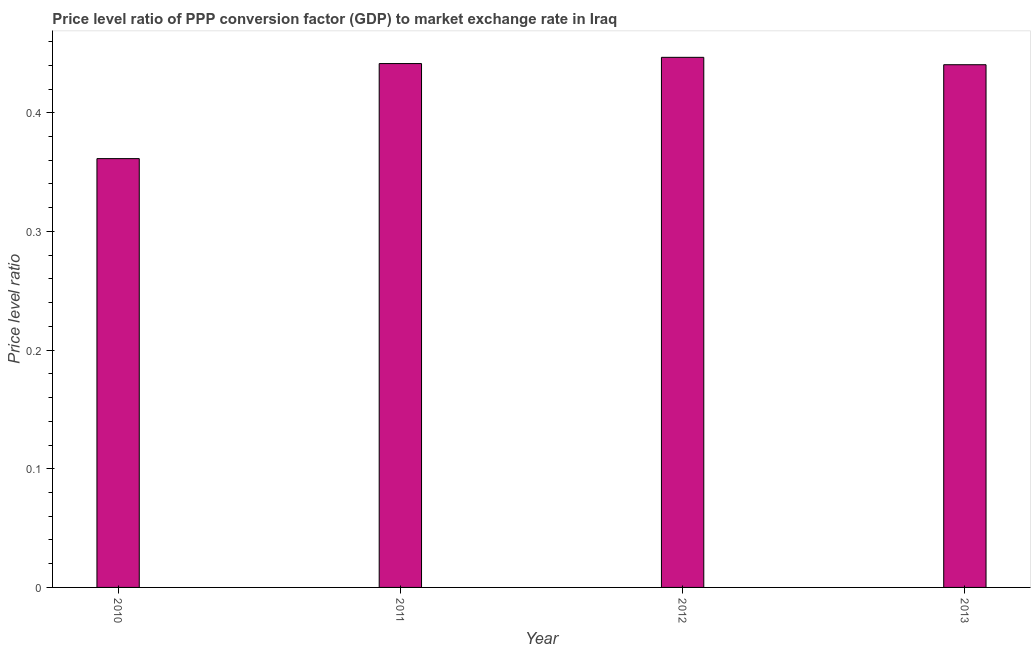What is the title of the graph?
Give a very brief answer. Price level ratio of PPP conversion factor (GDP) to market exchange rate in Iraq. What is the label or title of the Y-axis?
Your answer should be compact. Price level ratio. What is the price level ratio in 2013?
Your answer should be very brief. 0.44. Across all years, what is the maximum price level ratio?
Provide a succinct answer. 0.45. Across all years, what is the minimum price level ratio?
Your answer should be very brief. 0.36. In which year was the price level ratio maximum?
Your answer should be very brief. 2012. What is the sum of the price level ratio?
Your answer should be very brief. 1.69. What is the difference between the price level ratio in 2011 and 2012?
Provide a short and direct response. -0.01. What is the average price level ratio per year?
Provide a succinct answer. 0.42. What is the median price level ratio?
Ensure brevity in your answer.  0.44. Do a majority of the years between 2010 and 2012 (inclusive) have price level ratio greater than 0.14 ?
Your answer should be compact. Yes. Is the difference between the price level ratio in 2010 and 2013 greater than the difference between any two years?
Offer a terse response. No. What is the difference between the highest and the second highest price level ratio?
Your answer should be compact. 0.01. What is the difference between the highest and the lowest price level ratio?
Provide a short and direct response. 0.09. How many bars are there?
Provide a short and direct response. 4. Are all the bars in the graph horizontal?
Offer a very short reply. No. How many years are there in the graph?
Provide a succinct answer. 4. What is the difference between two consecutive major ticks on the Y-axis?
Offer a terse response. 0.1. Are the values on the major ticks of Y-axis written in scientific E-notation?
Your answer should be compact. No. What is the Price level ratio in 2010?
Your answer should be compact. 0.36. What is the Price level ratio of 2011?
Offer a very short reply. 0.44. What is the Price level ratio of 2012?
Your answer should be very brief. 0.45. What is the Price level ratio of 2013?
Provide a short and direct response. 0.44. What is the difference between the Price level ratio in 2010 and 2011?
Your answer should be very brief. -0.08. What is the difference between the Price level ratio in 2010 and 2012?
Offer a very short reply. -0.09. What is the difference between the Price level ratio in 2010 and 2013?
Ensure brevity in your answer.  -0.08. What is the difference between the Price level ratio in 2011 and 2012?
Provide a succinct answer. -0.01. What is the difference between the Price level ratio in 2011 and 2013?
Offer a very short reply. 0. What is the difference between the Price level ratio in 2012 and 2013?
Offer a very short reply. 0.01. What is the ratio of the Price level ratio in 2010 to that in 2011?
Offer a terse response. 0.82. What is the ratio of the Price level ratio in 2010 to that in 2012?
Ensure brevity in your answer.  0.81. What is the ratio of the Price level ratio in 2010 to that in 2013?
Offer a very short reply. 0.82. What is the ratio of the Price level ratio in 2011 to that in 2013?
Offer a very short reply. 1. 